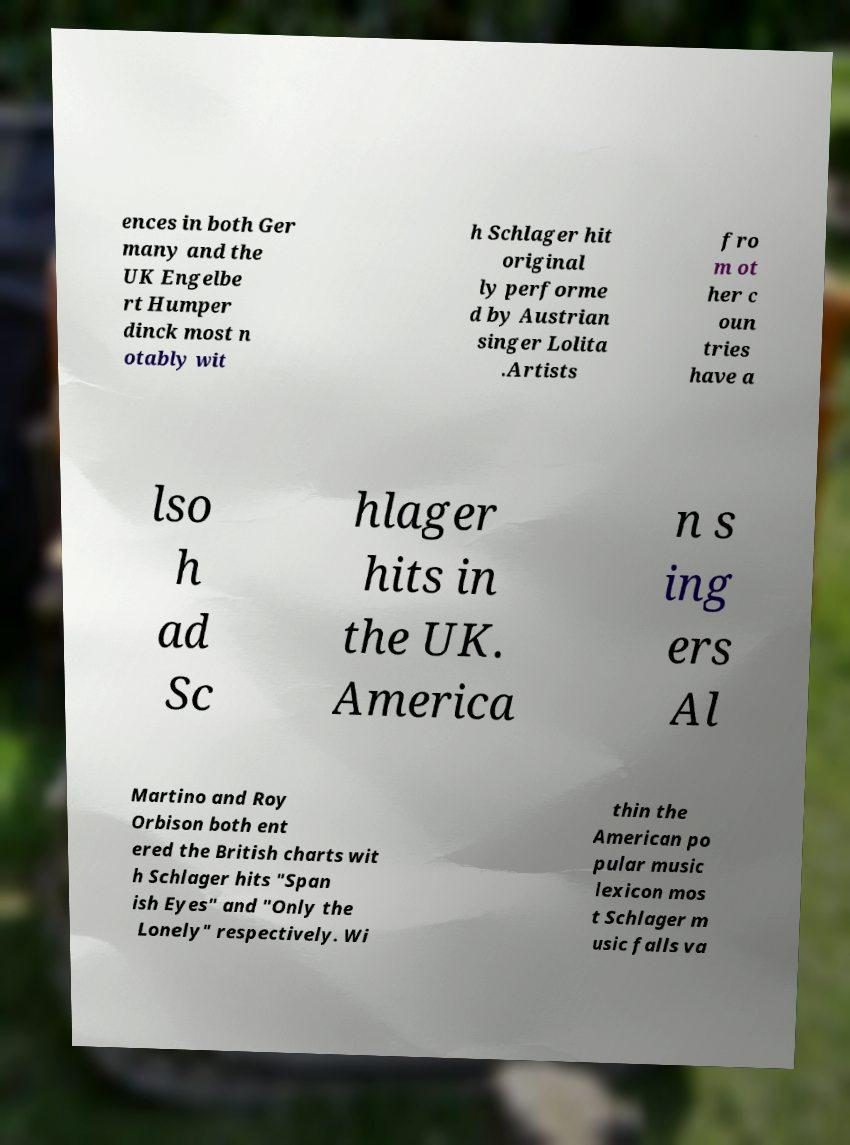For documentation purposes, I need the text within this image transcribed. Could you provide that? ences in both Ger many and the UK Engelbe rt Humper dinck most n otably wit h Schlager hit original ly performe d by Austrian singer Lolita .Artists fro m ot her c oun tries have a lso h ad Sc hlager hits in the UK. America n s ing ers Al Martino and Roy Orbison both ent ered the British charts wit h Schlager hits "Span ish Eyes" and "Only the Lonely" respectively. Wi thin the American po pular music lexicon mos t Schlager m usic falls va 